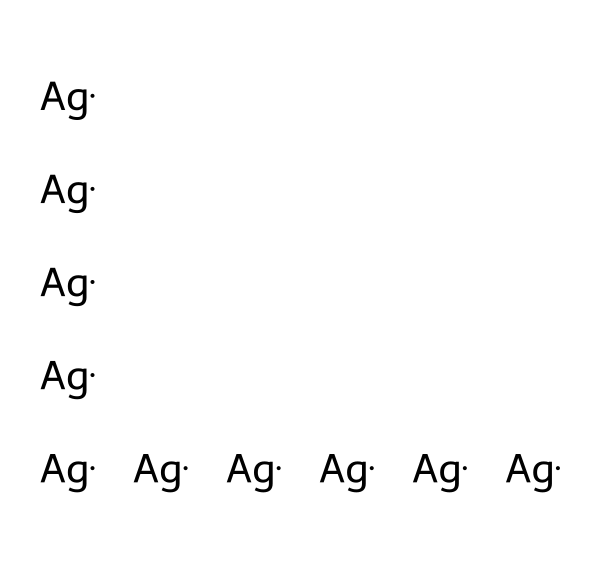What type of metal is represented in this structure? The SMILES representation indicates the presence of silver (Ag), which is a noble metal.
Answer: silver How many silver atoms are in this structure? The SMILES notation shows ten instances of "Ag," indicating there are ten silver atoms.
Answer: ten What is the unique property of silver nanoparticles relevant to wound dressings? Silver nanoparticles have antimicrobial properties, which help in preventing infections in wounds.
Answer: antimicrobial Are there any bonds present in this structure? Silver atoms can form metallic bonds, but there are no explicit covalent or ionic bonds shown in the SMILES; it primarily contains silver atoms.
Answer: no What type of chemical structure is formed with these silver atoms? The arrangement of silver atoms as indicated suggests a nanoparticle structure, typically found in colloidal systems.
Answer: nanoparticle What is the potential application of silver nanoparticles in medicine? Silver nanoparticles are used in wound dressings to promote healing and prevent infection due to their antimicrobial activity.
Answer: healing 